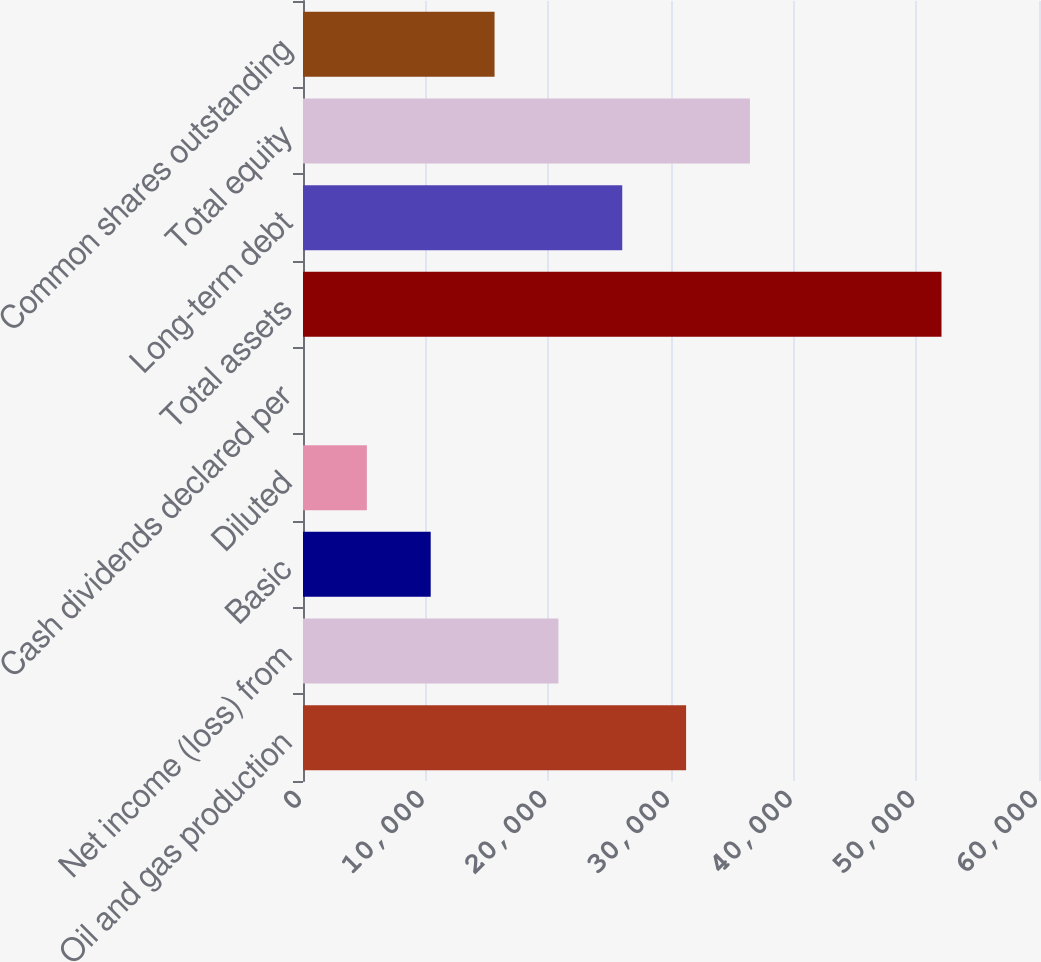Convert chart to OTSL. <chart><loc_0><loc_0><loc_500><loc_500><bar_chart><fcel>Oil and gas production<fcel>Net income (loss) from<fcel>Basic<fcel>Diluted<fcel>Cash dividends declared per<fcel>Total assets<fcel>Long-term debt<fcel>Total equity<fcel>Common shares outstanding<nl><fcel>31230.8<fcel>20820.8<fcel>10410.7<fcel>5205.64<fcel>0.6<fcel>52051<fcel>26025.8<fcel>36435.9<fcel>15615.7<nl></chart> 